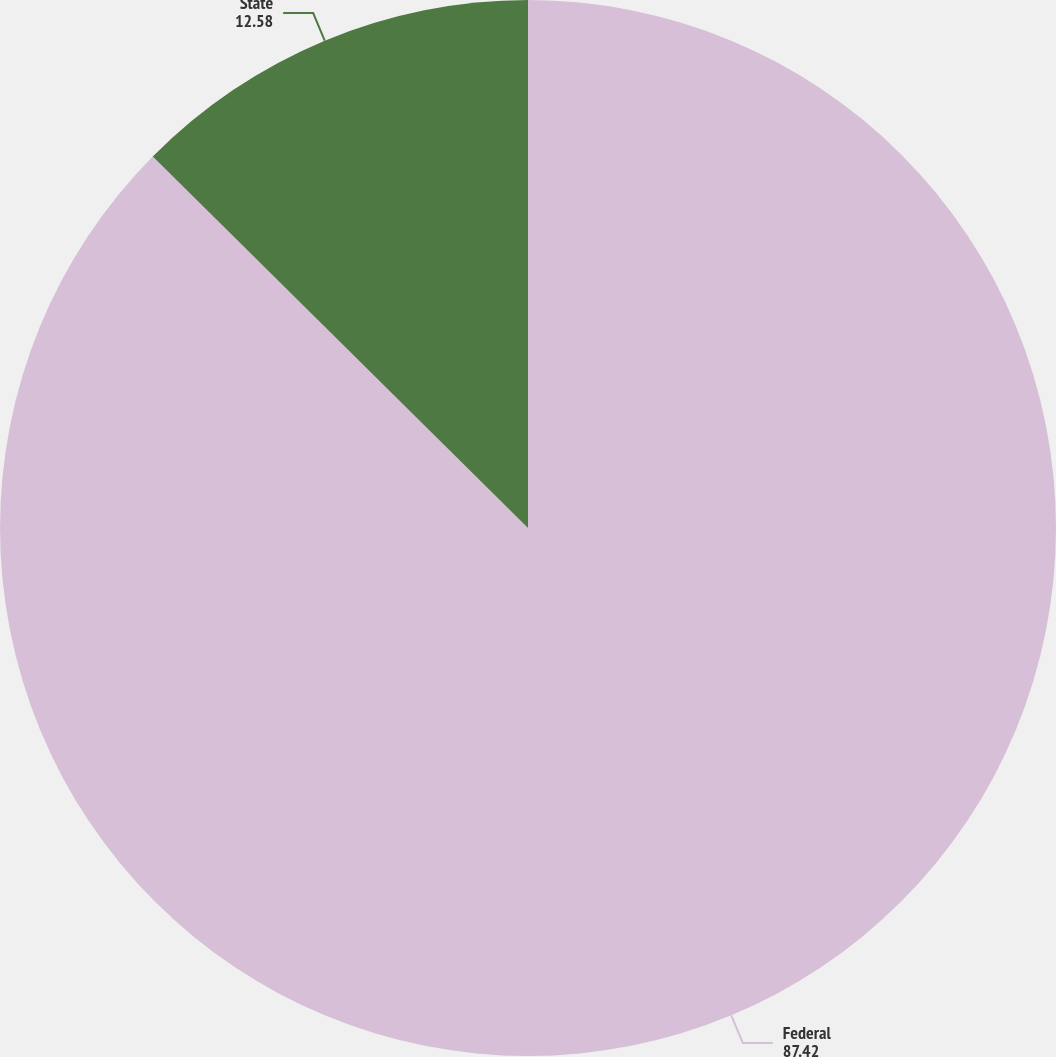Convert chart to OTSL. <chart><loc_0><loc_0><loc_500><loc_500><pie_chart><fcel>Federal<fcel>State<nl><fcel>87.42%<fcel>12.58%<nl></chart> 